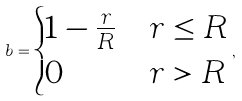<formula> <loc_0><loc_0><loc_500><loc_500>b = \begin{cases} 1 - \frac { r } { R } & r \leq R \\ 0 & r > R \end{cases} ,</formula> 